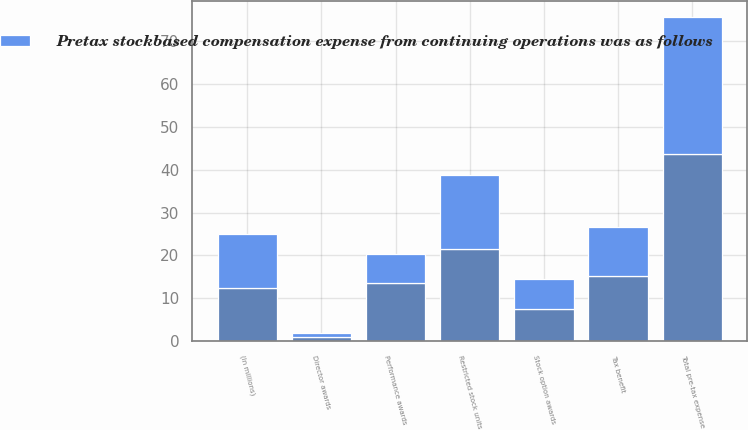<chart> <loc_0><loc_0><loc_500><loc_500><stacked_bar_chart><ecel><fcel>(In millions)<fcel>Stock option awards<fcel>Restricted stock units<fcel>Performance awards<fcel>Director awards<fcel>Total pre-tax expense<fcel>Tax benefit<nl><fcel>nan<fcel>12.5<fcel>7.4<fcel>21.6<fcel>13.6<fcel>1<fcel>43.6<fcel>15.2<nl><fcel>Pretax stockbased compensation expense from continuing operations was as follows<fcel>12.5<fcel>7.2<fcel>17.2<fcel>6.7<fcel>0.9<fcel>32<fcel>11.4<nl></chart> 